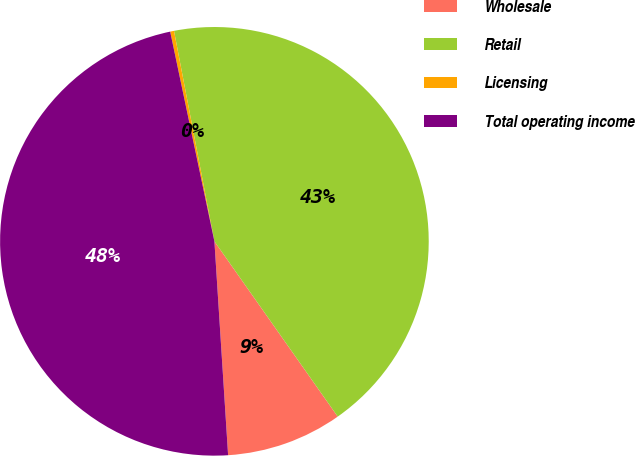<chart> <loc_0><loc_0><loc_500><loc_500><pie_chart><fcel>Wholesale<fcel>Retail<fcel>Licensing<fcel>Total operating income<nl><fcel>8.74%<fcel>43.26%<fcel>0.29%<fcel>47.71%<nl></chart> 